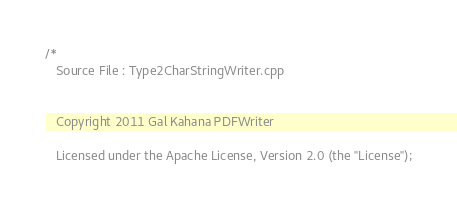<code> <loc_0><loc_0><loc_500><loc_500><_C++_>/*
   Source File : Type2CharStringWriter.cpp


   Copyright 2011 Gal Kahana PDFWriter

   Licensed under the Apache License, Version 2.0 (the "License");</code> 